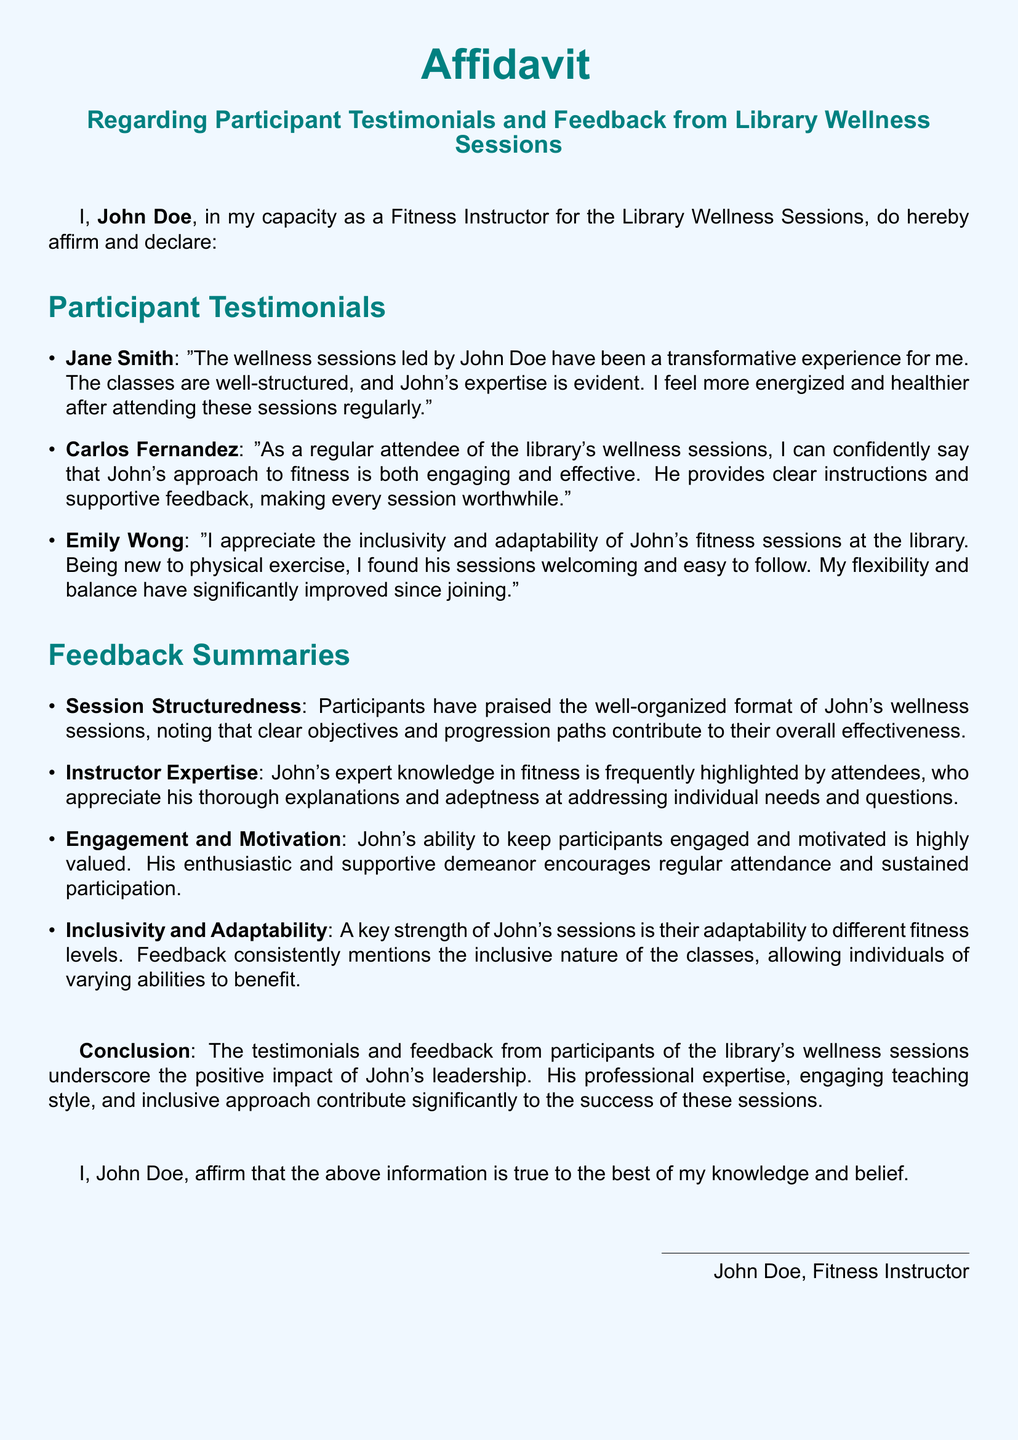What is the name of the Fitness Instructor? The instructor who leads the library's wellness sessions is named John Doe.
Answer: John Doe How many participant testimonials are included? The document lists three participant testimonials from individuals who attended the sessions.
Answer: Three What is one key strength of John's sessions mentioned in the feedback? The feedback highlights inclusivity and adaptability as a key strength of John's fitness sessions.
Answer: Inclusivity and adaptability Who expressed that they feel more energized after attending the sessions? Jane Smith provided a testimonial stating that she feels more energized after attending regularly.
Answer: Jane Smith What aspect of John's sessions contributes to overall effectiveness according to the feedback? Participants noted that the well-organized format and clear objectives contribute to the sessions' overall effectiveness.
Answer: Well-organized format What document type is this testimony presented as? The document is presented as an affidavit, which is a formal sworn statement.
Answer: Affidavit Which participant mentioned significant improvements in flexibility and balance? Emily Wong mentioned that her flexibility and balance have significantly improved since joining the sessions.
Answer: Emily Wong How does John Doe engage participants according to the feedback? Participants appreciate John's enthusiastic and supportive demeanor, which encourages regular attendance and participation.
Answer: Enthusiastic and supportive demeanor 